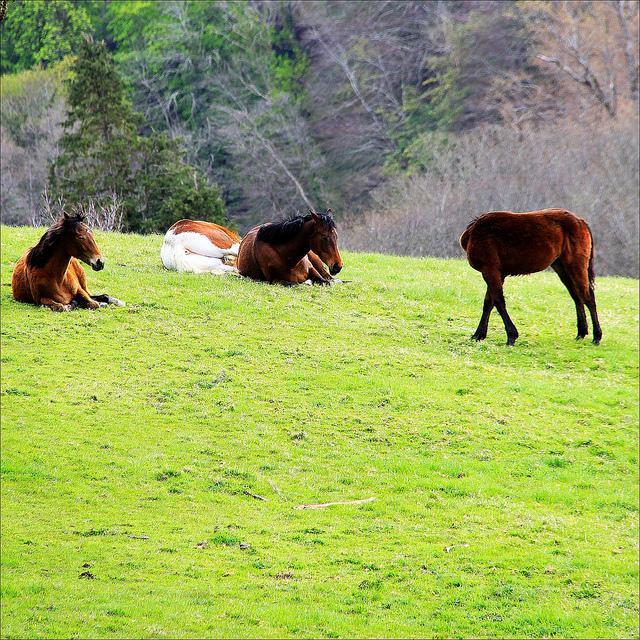How many horses are in the picture?
Give a very brief answer. 4. 